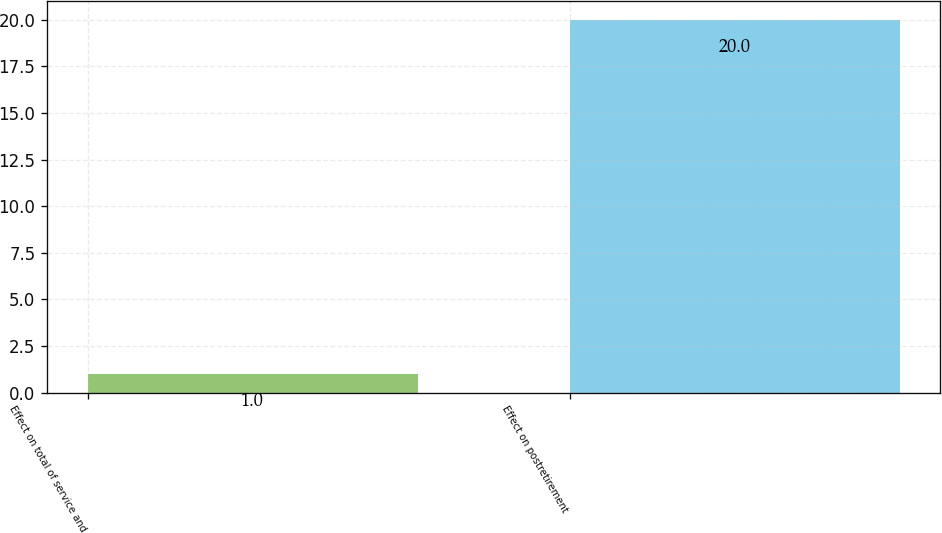Convert chart to OTSL. <chart><loc_0><loc_0><loc_500><loc_500><bar_chart><fcel>Effect on total of service and<fcel>Effect on postretirement<nl><fcel>1<fcel>20<nl></chart> 